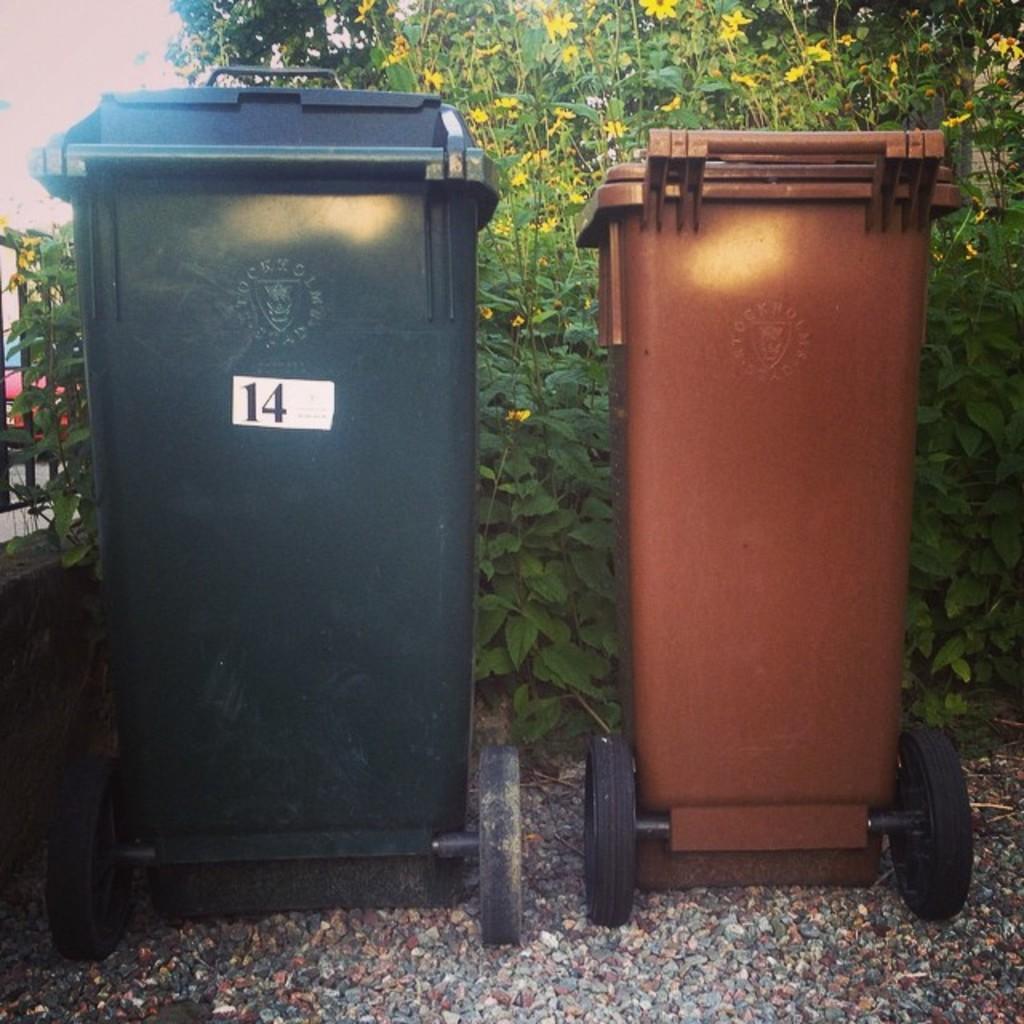Can you describe this image briefly? In this image there are two dustbins on the ground. Behind them there are plants. At the bottom there are stones on the ground. Beside them them there is a railing on the wall. Behind the railing there is a car on the road. 